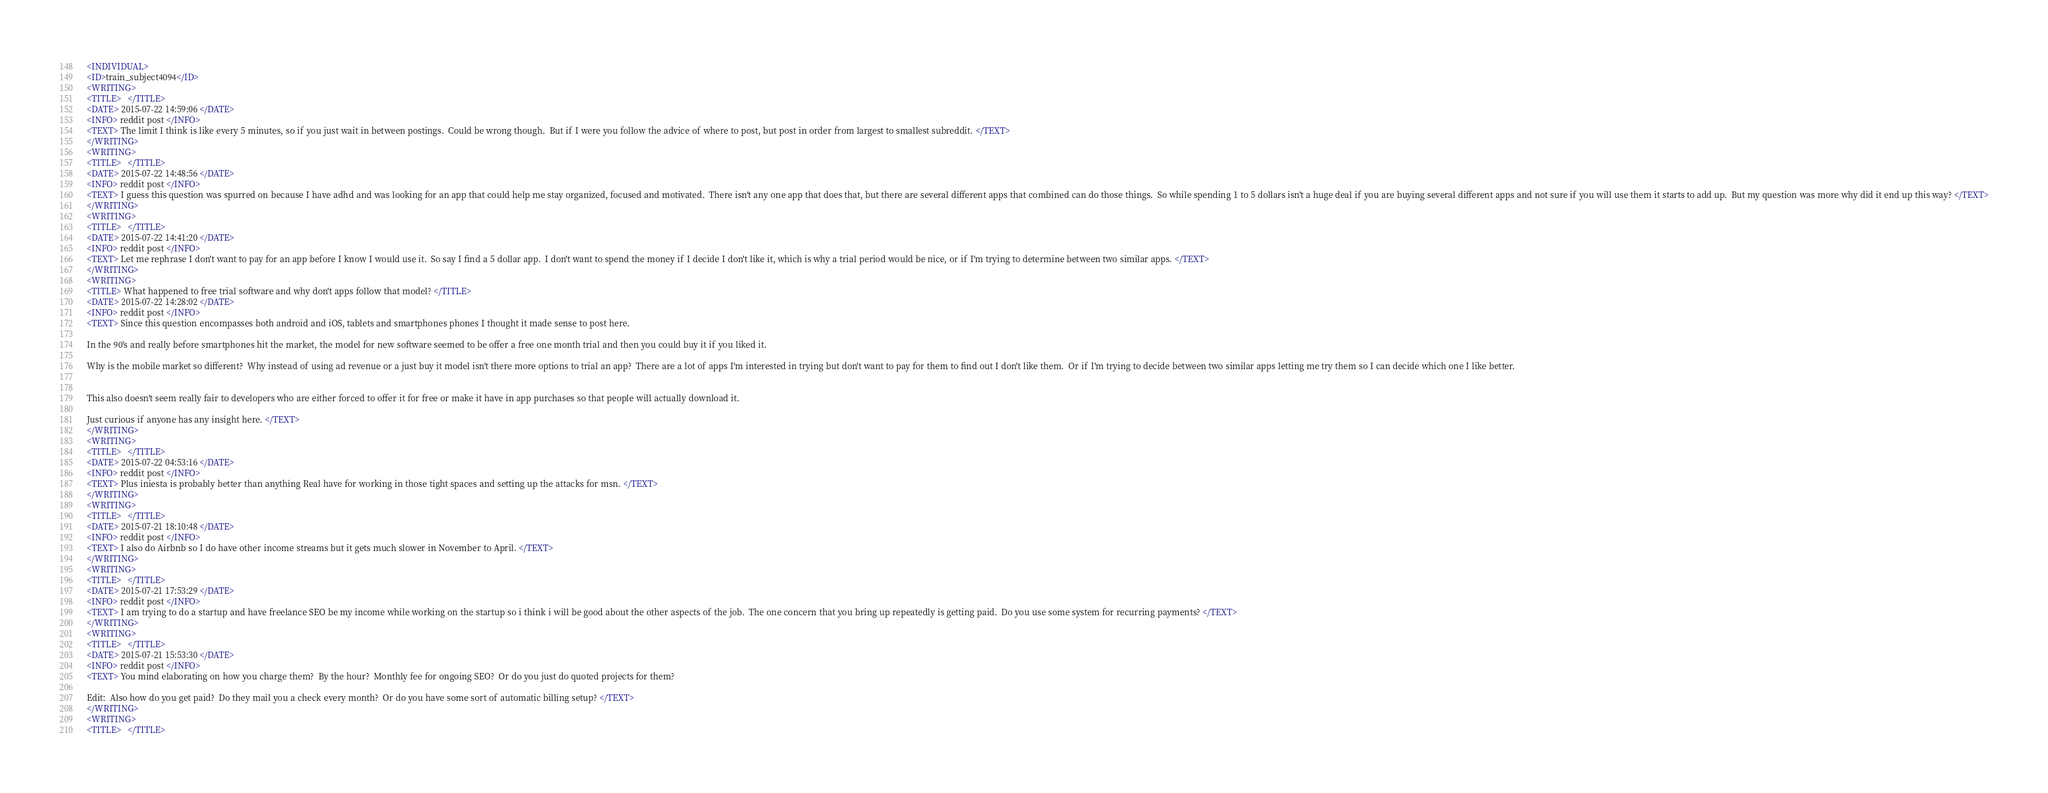<code> <loc_0><loc_0><loc_500><loc_500><_XML_><INDIVIDUAL>
<ID>train_subject4094</ID>
<WRITING>
<TITLE>   </TITLE>
<DATE> 2015-07-22 14:59:06 </DATE>
<INFO> reddit post </INFO>
<TEXT> The limit I think is like every 5 minutes, so if you just wait in between postings.  Could be wrong though.  But if I were you follow the advice of where to post, but post in order from largest to smallest subreddit. </TEXT>
</WRITING>
<WRITING>
<TITLE>   </TITLE>
<DATE> 2015-07-22 14:48:56 </DATE>
<INFO> reddit post </INFO>
<TEXT> I guess this question was spurred on because I have adhd and was looking for an app that could help me stay organized, focused and motivated.  There isn't any one app that does that, but there are several different apps that combined can do those things.  So while spending 1 to 5 dollars isn't a huge deal if you are buying several different apps and not sure if you will use them it starts to add up.  But my question was more why did it end up this way? </TEXT>
</WRITING>
<WRITING>
<TITLE>   </TITLE>
<DATE> 2015-07-22 14:41:20 </DATE>
<INFO> reddit post </INFO>
<TEXT> Let me rephrase I don't want to pay for an app before I know I would use it.  So say I find a 5 dollar app.  I don't want to spend the money if I decide I don't like it, which is why a trial period would be nice, or if I'm trying to determine between two similar apps. </TEXT>
</WRITING>
<WRITING>
<TITLE> What happened to free trial software and why don't apps follow that model? </TITLE>
<DATE> 2015-07-22 14:28:02 </DATE>
<INFO> reddit post </INFO>
<TEXT> Since this question encompasses both android and iOS, tablets and smartphones phones I thought it made sense to post here.

In the 90's and really before smartphones hit the market, the model for new software seemed to be offer a free one month trial and then you could buy it if you liked it.

Why is the mobile market so different?  Why instead of using ad revenue or a just buy it model isn't there more options to trial an app?  There are a lot of apps I'm interested in trying but don't want to pay for them to find out I don't like them.  Or if I'm trying to decide between two similar apps letting me try them so I can decide which one I like better.


This also doesn't seem really fair to developers who are either forced to offer it for free or make it have in app purchases so that people will actually download it.

Just curious if anyone has any insight here. </TEXT>
</WRITING>
<WRITING>
<TITLE>   </TITLE>
<DATE> 2015-07-22 04:53:16 </DATE>
<INFO> reddit post </INFO>
<TEXT> Plus iniesta is probably better than anything Real have for working in those tight spaces and setting up the attacks for msn. </TEXT>
</WRITING>
<WRITING>
<TITLE>   </TITLE>
<DATE> 2015-07-21 18:10:48 </DATE>
<INFO> reddit post </INFO>
<TEXT> I also do Airbnb so I do have other income streams but it gets much slower in November to April. </TEXT>
</WRITING>
<WRITING>
<TITLE>   </TITLE>
<DATE> 2015-07-21 17:53:29 </DATE>
<INFO> reddit post </INFO>
<TEXT> I am trying to do a startup and have freelance SEO be my income while working on the startup so i think i will be good about the other aspects of the job.  The one concern that you bring up repeatedly is getting paid.  Do you use some system for recurring payments? </TEXT>
</WRITING>
<WRITING>
<TITLE>   </TITLE>
<DATE> 2015-07-21 15:53:30 </DATE>
<INFO> reddit post </INFO>
<TEXT> You mind elaborating on how you charge them?  By the hour?  Monthly fee for ongoing SEO?  Or do you just do quoted projects for them?

Edit:  Also how do you get paid?  Do they mail you a check every month?  Or do you have some sort of automatic billing setup? </TEXT>
</WRITING>
<WRITING>
<TITLE>   </TITLE></code> 